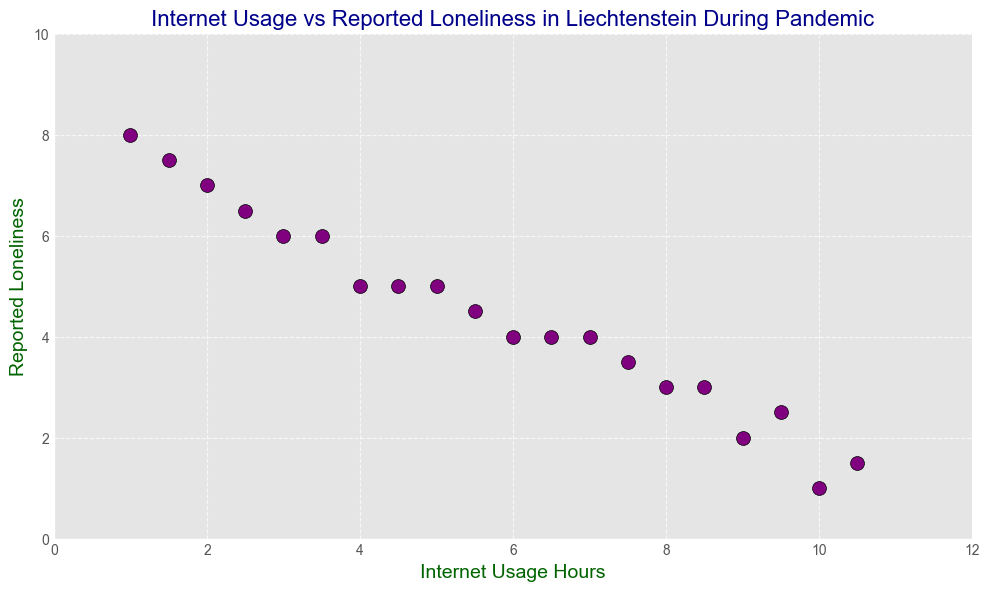What is the title of the figure? The title is located at the top of the figure in large font.
Answer: Internet Usage vs Reported Loneliness in Liechtenstein During Pandemic How many hours of internet usage are reported for the least lonely feeling? Look for the data point with the smallest value on the Reported Loneliness axes and identify its corresponding Internet Usage Hours.
Answer: 10 What is the average reported loneliness for internet usage of 4 and 5 hours? Find the Reported Loneliness values for 4 and 5 hours of Internet Usage Hours which are both equal to 5. The average is: (5 + 5) / 2
Answer: 5 Which data point has more reported loneliness, 2 hours or 8 hours of internet usage? Compare the Reported Loneliness values for 2 hours (7) and 8 hours (3) of Internet Usage Hours. 7 is greater than 3.
Answer: 2 hours How does reported loneliness change as internet usage increases from 6 to 10 hours? Observe the trend in the data points for Internet Usage Hours from 6 to 10 and note the decreasing Reported Loneliness.
Answer: Decreases Which color is used for the markers on the scatter plot? Identify the color of the data points from the figure.
Answer: Purple What is the range of reported loneliness values in the plot? Find the minimum and maximum values on the Reported Loneliness axis. The range goes from 1 to 8.
Answer: 1 to 8 Is there an outlier data point in terms of internet usage hours? Look at the spread of data points along the Internet Usage Hours axis to see if any data point stands out.
Answer: No Between internet usage of 3 and 7 hours, how many different reported feelings of loneliness values can be seen? Identify unique Reported Loneliness values for Internet Usage Hours between 3 and 7. They are 6, 5, 4.5, and 4.
Answer: 4 What is the trend visible between internet usage and reported loneliness? Examine the scatter plot to determine the overall relationship trend between Internet Usage Hours and Reported Loneliness.
Answer: Negative correlation 